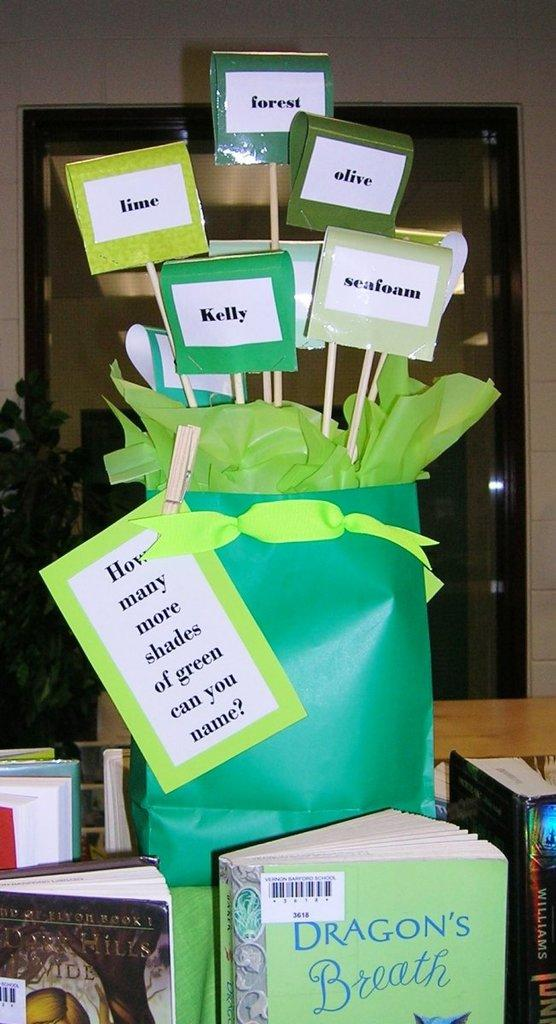<image>
Offer a succinct explanation of the picture presented. Some examples of the shades of green include: seafoam, olive, forest and lime. 